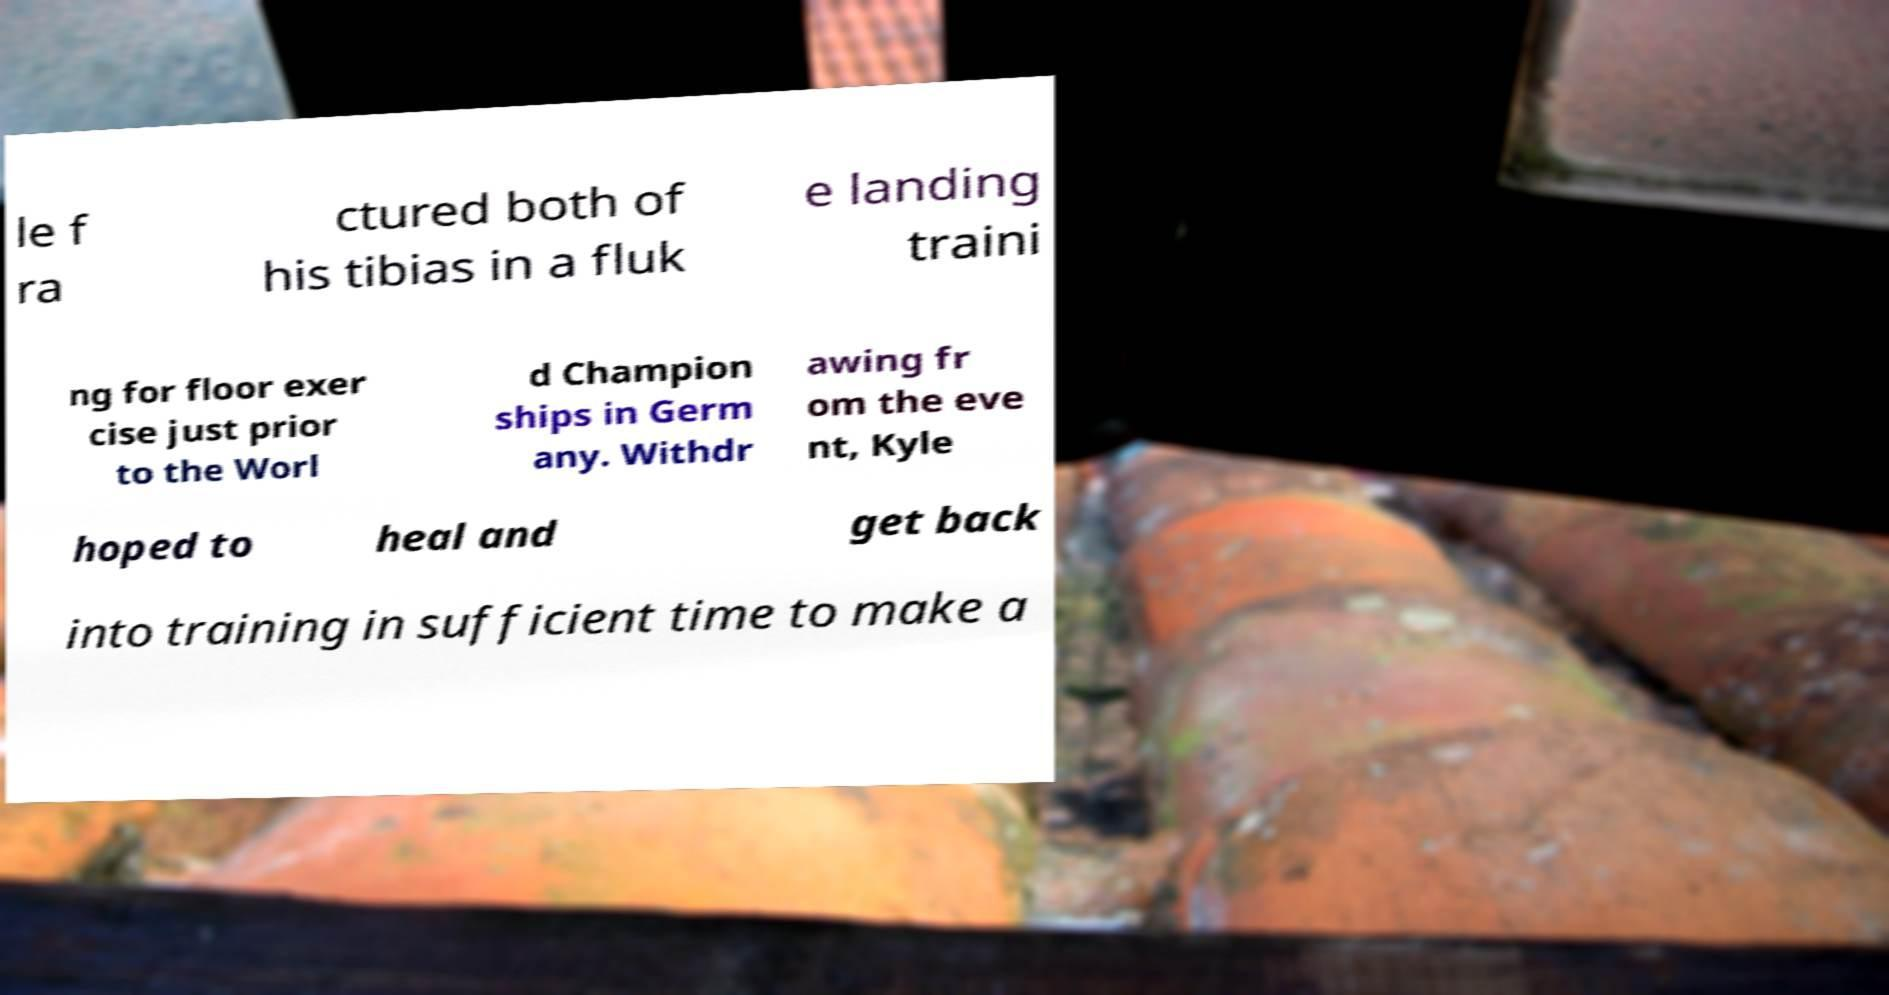What messages or text are displayed in this image? I need them in a readable, typed format. le f ra ctured both of his tibias in a fluk e landing traini ng for floor exer cise just prior to the Worl d Champion ships in Germ any. Withdr awing fr om the eve nt, Kyle hoped to heal and get back into training in sufficient time to make a 